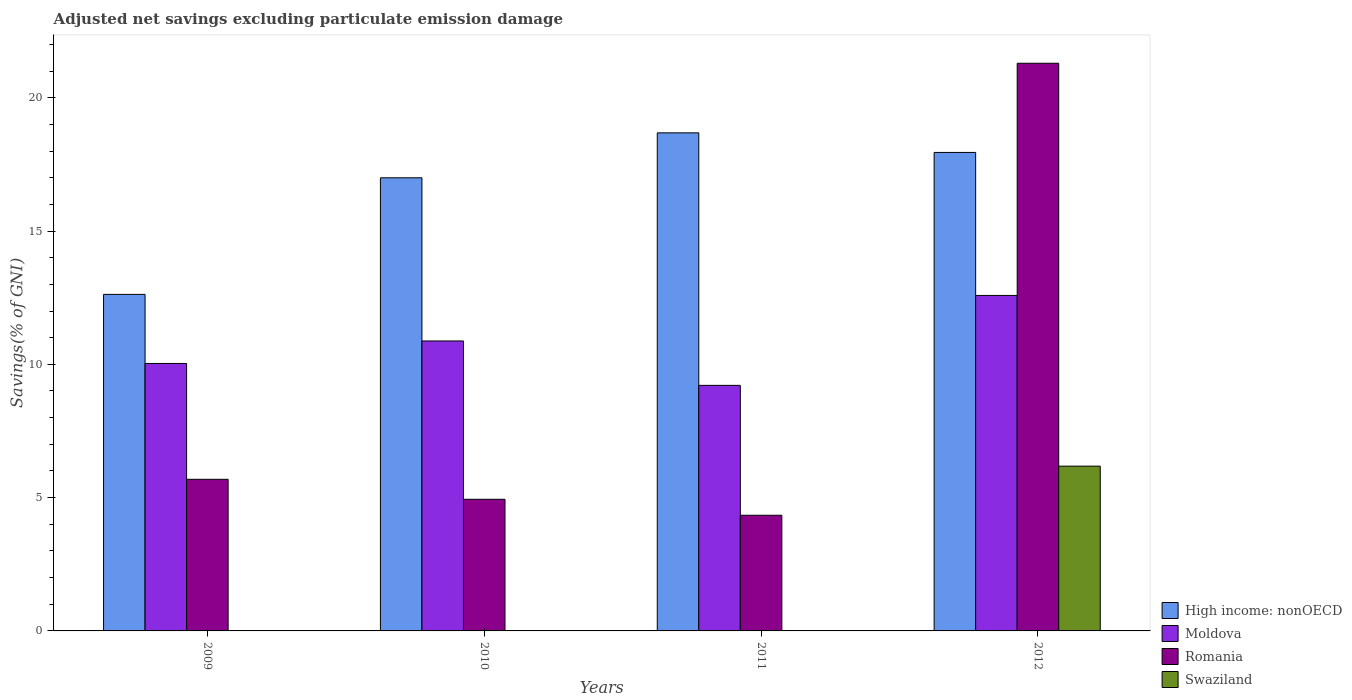How many different coloured bars are there?
Offer a very short reply. 4. Are the number of bars per tick equal to the number of legend labels?
Your answer should be compact. No. Are the number of bars on each tick of the X-axis equal?
Provide a short and direct response. No. How many bars are there on the 1st tick from the left?
Give a very brief answer. 3. How many bars are there on the 1st tick from the right?
Ensure brevity in your answer.  4. What is the label of the 2nd group of bars from the left?
Your answer should be compact. 2010. What is the adjusted net savings in Moldova in 2012?
Ensure brevity in your answer.  12.58. Across all years, what is the maximum adjusted net savings in Moldova?
Provide a short and direct response. 12.58. Across all years, what is the minimum adjusted net savings in High income: nonOECD?
Your response must be concise. 12.62. What is the total adjusted net savings in High income: nonOECD in the graph?
Provide a short and direct response. 66.25. What is the difference between the adjusted net savings in High income: nonOECD in 2010 and that in 2011?
Ensure brevity in your answer.  -1.69. What is the difference between the adjusted net savings in High income: nonOECD in 2009 and the adjusted net savings in Swaziland in 2012?
Provide a short and direct response. 6.44. What is the average adjusted net savings in Moldova per year?
Keep it short and to the point. 10.68. In the year 2012, what is the difference between the adjusted net savings in Romania and adjusted net savings in Swaziland?
Your answer should be compact. 15.11. What is the ratio of the adjusted net savings in Moldova in 2011 to that in 2012?
Offer a terse response. 0.73. Is the adjusted net savings in Moldova in 2010 less than that in 2011?
Provide a short and direct response. No. What is the difference between the highest and the second highest adjusted net savings in Romania?
Your answer should be compact. 15.61. What is the difference between the highest and the lowest adjusted net savings in Swaziland?
Your answer should be very brief. 6.18. In how many years, is the adjusted net savings in Romania greater than the average adjusted net savings in Romania taken over all years?
Your response must be concise. 1. Is the sum of the adjusted net savings in Romania in 2010 and 2012 greater than the maximum adjusted net savings in Moldova across all years?
Give a very brief answer. Yes. Is it the case that in every year, the sum of the adjusted net savings in Swaziland and adjusted net savings in Moldova is greater than the sum of adjusted net savings in Romania and adjusted net savings in High income: nonOECD?
Your response must be concise. Yes. Is it the case that in every year, the sum of the adjusted net savings in Romania and adjusted net savings in Swaziland is greater than the adjusted net savings in Moldova?
Offer a very short reply. No. How many bars are there?
Offer a very short reply. 13. What is the difference between two consecutive major ticks on the Y-axis?
Make the answer very short. 5. Does the graph contain grids?
Offer a terse response. No. Where does the legend appear in the graph?
Your response must be concise. Bottom right. What is the title of the graph?
Your response must be concise. Adjusted net savings excluding particulate emission damage. What is the label or title of the X-axis?
Provide a short and direct response. Years. What is the label or title of the Y-axis?
Ensure brevity in your answer.  Savings(% of GNI). What is the Savings(% of GNI) of High income: nonOECD in 2009?
Your response must be concise. 12.62. What is the Savings(% of GNI) of Moldova in 2009?
Keep it short and to the point. 10.03. What is the Savings(% of GNI) in Romania in 2009?
Provide a succinct answer. 5.69. What is the Savings(% of GNI) of High income: nonOECD in 2010?
Provide a short and direct response. 17. What is the Savings(% of GNI) of Moldova in 2010?
Provide a short and direct response. 10.88. What is the Savings(% of GNI) of Romania in 2010?
Provide a succinct answer. 4.94. What is the Savings(% of GNI) of High income: nonOECD in 2011?
Ensure brevity in your answer.  18.68. What is the Savings(% of GNI) of Moldova in 2011?
Ensure brevity in your answer.  9.21. What is the Savings(% of GNI) of Romania in 2011?
Your answer should be compact. 4.34. What is the Savings(% of GNI) in High income: nonOECD in 2012?
Make the answer very short. 17.95. What is the Savings(% of GNI) of Moldova in 2012?
Offer a very short reply. 12.58. What is the Savings(% of GNI) in Romania in 2012?
Offer a very short reply. 21.29. What is the Savings(% of GNI) in Swaziland in 2012?
Keep it short and to the point. 6.18. Across all years, what is the maximum Savings(% of GNI) of High income: nonOECD?
Provide a succinct answer. 18.68. Across all years, what is the maximum Savings(% of GNI) of Moldova?
Ensure brevity in your answer.  12.58. Across all years, what is the maximum Savings(% of GNI) of Romania?
Your answer should be compact. 21.29. Across all years, what is the maximum Savings(% of GNI) of Swaziland?
Provide a succinct answer. 6.18. Across all years, what is the minimum Savings(% of GNI) in High income: nonOECD?
Give a very brief answer. 12.62. Across all years, what is the minimum Savings(% of GNI) in Moldova?
Your answer should be compact. 9.21. Across all years, what is the minimum Savings(% of GNI) of Romania?
Provide a succinct answer. 4.34. What is the total Savings(% of GNI) of High income: nonOECD in the graph?
Provide a short and direct response. 66.25. What is the total Savings(% of GNI) of Moldova in the graph?
Provide a short and direct response. 42.7. What is the total Savings(% of GNI) of Romania in the graph?
Offer a very short reply. 36.26. What is the total Savings(% of GNI) of Swaziland in the graph?
Offer a terse response. 6.18. What is the difference between the Savings(% of GNI) of High income: nonOECD in 2009 and that in 2010?
Ensure brevity in your answer.  -4.37. What is the difference between the Savings(% of GNI) of Moldova in 2009 and that in 2010?
Offer a terse response. -0.84. What is the difference between the Savings(% of GNI) of Romania in 2009 and that in 2010?
Provide a short and direct response. 0.75. What is the difference between the Savings(% of GNI) in High income: nonOECD in 2009 and that in 2011?
Ensure brevity in your answer.  -6.06. What is the difference between the Savings(% of GNI) in Moldova in 2009 and that in 2011?
Your response must be concise. 0.82. What is the difference between the Savings(% of GNI) of Romania in 2009 and that in 2011?
Give a very brief answer. 1.35. What is the difference between the Savings(% of GNI) of High income: nonOECD in 2009 and that in 2012?
Make the answer very short. -5.32. What is the difference between the Savings(% of GNI) in Moldova in 2009 and that in 2012?
Offer a very short reply. -2.55. What is the difference between the Savings(% of GNI) in Romania in 2009 and that in 2012?
Keep it short and to the point. -15.61. What is the difference between the Savings(% of GNI) of High income: nonOECD in 2010 and that in 2011?
Provide a succinct answer. -1.69. What is the difference between the Savings(% of GNI) in Moldova in 2010 and that in 2011?
Your answer should be very brief. 1.67. What is the difference between the Savings(% of GNI) of Romania in 2010 and that in 2011?
Your answer should be very brief. 0.6. What is the difference between the Savings(% of GNI) in High income: nonOECD in 2010 and that in 2012?
Ensure brevity in your answer.  -0.95. What is the difference between the Savings(% of GNI) of Moldova in 2010 and that in 2012?
Give a very brief answer. -1.71. What is the difference between the Savings(% of GNI) of Romania in 2010 and that in 2012?
Provide a succinct answer. -16.36. What is the difference between the Savings(% of GNI) of High income: nonOECD in 2011 and that in 2012?
Give a very brief answer. 0.73. What is the difference between the Savings(% of GNI) of Moldova in 2011 and that in 2012?
Your answer should be very brief. -3.37. What is the difference between the Savings(% of GNI) in Romania in 2011 and that in 2012?
Your response must be concise. -16.95. What is the difference between the Savings(% of GNI) of High income: nonOECD in 2009 and the Savings(% of GNI) of Moldova in 2010?
Offer a very short reply. 1.75. What is the difference between the Savings(% of GNI) in High income: nonOECD in 2009 and the Savings(% of GNI) in Romania in 2010?
Your answer should be very brief. 7.69. What is the difference between the Savings(% of GNI) of Moldova in 2009 and the Savings(% of GNI) of Romania in 2010?
Provide a succinct answer. 5.09. What is the difference between the Savings(% of GNI) in High income: nonOECD in 2009 and the Savings(% of GNI) in Moldova in 2011?
Your answer should be very brief. 3.41. What is the difference between the Savings(% of GNI) of High income: nonOECD in 2009 and the Savings(% of GNI) of Romania in 2011?
Keep it short and to the point. 8.29. What is the difference between the Savings(% of GNI) in Moldova in 2009 and the Savings(% of GNI) in Romania in 2011?
Give a very brief answer. 5.69. What is the difference between the Savings(% of GNI) of High income: nonOECD in 2009 and the Savings(% of GNI) of Moldova in 2012?
Provide a short and direct response. 0.04. What is the difference between the Savings(% of GNI) of High income: nonOECD in 2009 and the Savings(% of GNI) of Romania in 2012?
Keep it short and to the point. -8.67. What is the difference between the Savings(% of GNI) of High income: nonOECD in 2009 and the Savings(% of GNI) of Swaziland in 2012?
Make the answer very short. 6.44. What is the difference between the Savings(% of GNI) in Moldova in 2009 and the Savings(% of GNI) in Romania in 2012?
Offer a very short reply. -11.26. What is the difference between the Savings(% of GNI) of Moldova in 2009 and the Savings(% of GNI) of Swaziland in 2012?
Offer a very short reply. 3.85. What is the difference between the Savings(% of GNI) in Romania in 2009 and the Savings(% of GNI) in Swaziland in 2012?
Provide a succinct answer. -0.49. What is the difference between the Savings(% of GNI) of High income: nonOECD in 2010 and the Savings(% of GNI) of Moldova in 2011?
Your response must be concise. 7.79. What is the difference between the Savings(% of GNI) of High income: nonOECD in 2010 and the Savings(% of GNI) of Romania in 2011?
Offer a terse response. 12.66. What is the difference between the Savings(% of GNI) in Moldova in 2010 and the Savings(% of GNI) in Romania in 2011?
Your answer should be compact. 6.54. What is the difference between the Savings(% of GNI) of High income: nonOECD in 2010 and the Savings(% of GNI) of Moldova in 2012?
Give a very brief answer. 4.41. What is the difference between the Savings(% of GNI) in High income: nonOECD in 2010 and the Savings(% of GNI) in Romania in 2012?
Your answer should be compact. -4.3. What is the difference between the Savings(% of GNI) in High income: nonOECD in 2010 and the Savings(% of GNI) in Swaziland in 2012?
Your answer should be very brief. 10.82. What is the difference between the Savings(% of GNI) in Moldova in 2010 and the Savings(% of GNI) in Romania in 2012?
Offer a terse response. -10.42. What is the difference between the Savings(% of GNI) in Moldova in 2010 and the Savings(% of GNI) in Swaziland in 2012?
Make the answer very short. 4.7. What is the difference between the Savings(% of GNI) in Romania in 2010 and the Savings(% of GNI) in Swaziland in 2012?
Provide a succinct answer. -1.24. What is the difference between the Savings(% of GNI) in High income: nonOECD in 2011 and the Savings(% of GNI) in Moldova in 2012?
Your answer should be compact. 6.1. What is the difference between the Savings(% of GNI) of High income: nonOECD in 2011 and the Savings(% of GNI) of Romania in 2012?
Provide a short and direct response. -2.61. What is the difference between the Savings(% of GNI) of High income: nonOECD in 2011 and the Savings(% of GNI) of Swaziland in 2012?
Ensure brevity in your answer.  12.5. What is the difference between the Savings(% of GNI) of Moldova in 2011 and the Savings(% of GNI) of Romania in 2012?
Offer a very short reply. -12.08. What is the difference between the Savings(% of GNI) of Moldova in 2011 and the Savings(% of GNI) of Swaziland in 2012?
Provide a succinct answer. 3.03. What is the difference between the Savings(% of GNI) of Romania in 2011 and the Savings(% of GNI) of Swaziland in 2012?
Keep it short and to the point. -1.84. What is the average Savings(% of GNI) of High income: nonOECD per year?
Offer a very short reply. 16.56. What is the average Savings(% of GNI) of Moldova per year?
Your answer should be compact. 10.68. What is the average Savings(% of GNI) in Romania per year?
Offer a terse response. 9.06. What is the average Savings(% of GNI) of Swaziland per year?
Keep it short and to the point. 1.55. In the year 2009, what is the difference between the Savings(% of GNI) of High income: nonOECD and Savings(% of GNI) of Moldova?
Ensure brevity in your answer.  2.59. In the year 2009, what is the difference between the Savings(% of GNI) in High income: nonOECD and Savings(% of GNI) in Romania?
Give a very brief answer. 6.94. In the year 2009, what is the difference between the Savings(% of GNI) of Moldova and Savings(% of GNI) of Romania?
Offer a terse response. 4.35. In the year 2010, what is the difference between the Savings(% of GNI) of High income: nonOECD and Savings(% of GNI) of Moldova?
Provide a short and direct response. 6.12. In the year 2010, what is the difference between the Savings(% of GNI) of High income: nonOECD and Savings(% of GNI) of Romania?
Keep it short and to the point. 12.06. In the year 2010, what is the difference between the Savings(% of GNI) in Moldova and Savings(% of GNI) in Romania?
Give a very brief answer. 5.94. In the year 2011, what is the difference between the Savings(% of GNI) in High income: nonOECD and Savings(% of GNI) in Moldova?
Keep it short and to the point. 9.47. In the year 2011, what is the difference between the Savings(% of GNI) in High income: nonOECD and Savings(% of GNI) in Romania?
Ensure brevity in your answer.  14.34. In the year 2011, what is the difference between the Savings(% of GNI) in Moldova and Savings(% of GNI) in Romania?
Give a very brief answer. 4.87. In the year 2012, what is the difference between the Savings(% of GNI) of High income: nonOECD and Savings(% of GNI) of Moldova?
Offer a very short reply. 5.37. In the year 2012, what is the difference between the Savings(% of GNI) in High income: nonOECD and Savings(% of GNI) in Romania?
Provide a succinct answer. -3.34. In the year 2012, what is the difference between the Savings(% of GNI) in High income: nonOECD and Savings(% of GNI) in Swaziland?
Your answer should be very brief. 11.77. In the year 2012, what is the difference between the Savings(% of GNI) of Moldova and Savings(% of GNI) of Romania?
Your response must be concise. -8.71. In the year 2012, what is the difference between the Savings(% of GNI) of Moldova and Savings(% of GNI) of Swaziland?
Offer a very short reply. 6.4. In the year 2012, what is the difference between the Savings(% of GNI) in Romania and Savings(% of GNI) in Swaziland?
Ensure brevity in your answer.  15.11. What is the ratio of the Savings(% of GNI) of High income: nonOECD in 2009 to that in 2010?
Provide a succinct answer. 0.74. What is the ratio of the Savings(% of GNI) of Moldova in 2009 to that in 2010?
Your response must be concise. 0.92. What is the ratio of the Savings(% of GNI) of Romania in 2009 to that in 2010?
Make the answer very short. 1.15. What is the ratio of the Savings(% of GNI) of High income: nonOECD in 2009 to that in 2011?
Keep it short and to the point. 0.68. What is the ratio of the Savings(% of GNI) in Moldova in 2009 to that in 2011?
Your answer should be very brief. 1.09. What is the ratio of the Savings(% of GNI) in Romania in 2009 to that in 2011?
Offer a very short reply. 1.31. What is the ratio of the Savings(% of GNI) in High income: nonOECD in 2009 to that in 2012?
Your answer should be very brief. 0.7. What is the ratio of the Savings(% of GNI) of Moldova in 2009 to that in 2012?
Make the answer very short. 0.8. What is the ratio of the Savings(% of GNI) in Romania in 2009 to that in 2012?
Your answer should be very brief. 0.27. What is the ratio of the Savings(% of GNI) in High income: nonOECD in 2010 to that in 2011?
Keep it short and to the point. 0.91. What is the ratio of the Savings(% of GNI) of Moldova in 2010 to that in 2011?
Give a very brief answer. 1.18. What is the ratio of the Savings(% of GNI) of Romania in 2010 to that in 2011?
Provide a succinct answer. 1.14. What is the ratio of the Savings(% of GNI) in High income: nonOECD in 2010 to that in 2012?
Ensure brevity in your answer.  0.95. What is the ratio of the Savings(% of GNI) in Moldova in 2010 to that in 2012?
Your answer should be very brief. 0.86. What is the ratio of the Savings(% of GNI) in Romania in 2010 to that in 2012?
Give a very brief answer. 0.23. What is the ratio of the Savings(% of GNI) of High income: nonOECD in 2011 to that in 2012?
Provide a short and direct response. 1.04. What is the ratio of the Savings(% of GNI) of Moldova in 2011 to that in 2012?
Offer a terse response. 0.73. What is the ratio of the Savings(% of GNI) of Romania in 2011 to that in 2012?
Your answer should be compact. 0.2. What is the difference between the highest and the second highest Savings(% of GNI) in High income: nonOECD?
Ensure brevity in your answer.  0.73. What is the difference between the highest and the second highest Savings(% of GNI) of Moldova?
Give a very brief answer. 1.71. What is the difference between the highest and the second highest Savings(% of GNI) in Romania?
Make the answer very short. 15.61. What is the difference between the highest and the lowest Savings(% of GNI) in High income: nonOECD?
Offer a terse response. 6.06. What is the difference between the highest and the lowest Savings(% of GNI) in Moldova?
Offer a very short reply. 3.37. What is the difference between the highest and the lowest Savings(% of GNI) of Romania?
Keep it short and to the point. 16.95. What is the difference between the highest and the lowest Savings(% of GNI) in Swaziland?
Provide a short and direct response. 6.18. 